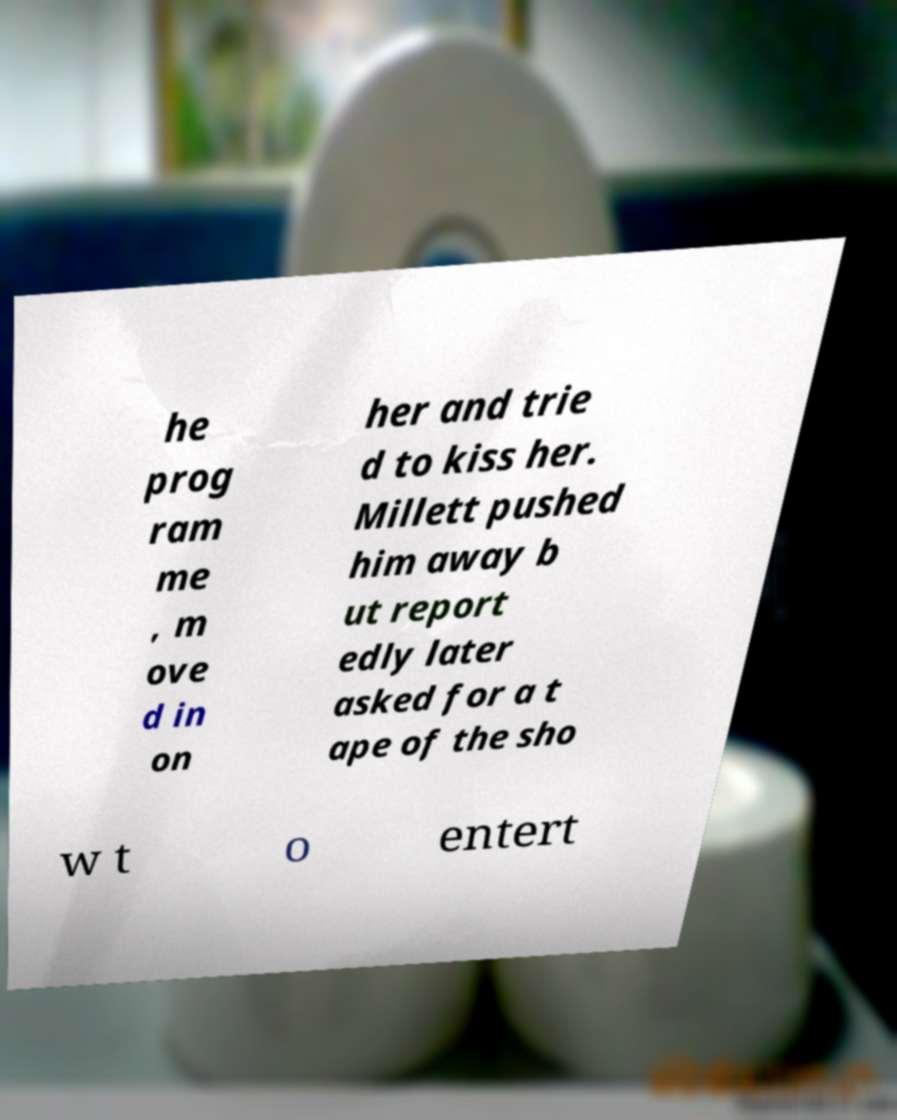What messages or text are displayed in this image? I need them in a readable, typed format. he prog ram me , m ove d in on her and trie d to kiss her. Millett pushed him away b ut report edly later asked for a t ape of the sho w t o entert 